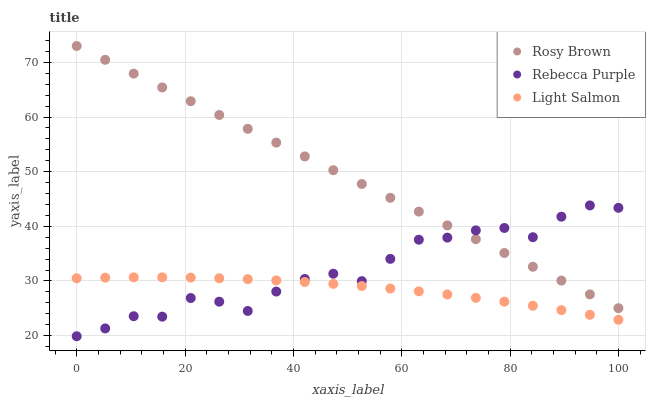Does Light Salmon have the minimum area under the curve?
Answer yes or no. Yes. Does Rosy Brown have the maximum area under the curve?
Answer yes or no. Yes. Does Rebecca Purple have the minimum area under the curve?
Answer yes or no. No. Does Rebecca Purple have the maximum area under the curve?
Answer yes or no. No. Is Rosy Brown the smoothest?
Answer yes or no. Yes. Is Rebecca Purple the roughest?
Answer yes or no. Yes. Is Rebecca Purple the smoothest?
Answer yes or no. No. Is Rosy Brown the roughest?
Answer yes or no. No. Does Rebecca Purple have the lowest value?
Answer yes or no. Yes. Does Rosy Brown have the lowest value?
Answer yes or no. No. Does Rosy Brown have the highest value?
Answer yes or no. Yes. Does Rebecca Purple have the highest value?
Answer yes or no. No. Is Light Salmon less than Rosy Brown?
Answer yes or no. Yes. Is Rosy Brown greater than Light Salmon?
Answer yes or no. Yes. Does Rebecca Purple intersect Rosy Brown?
Answer yes or no. Yes. Is Rebecca Purple less than Rosy Brown?
Answer yes or no. No. Is Rebecca Purple greater than Rosy Brown?
Answer yes or no. No. Does Light Salmon intersect Rosy Brown?
Answer yes or no. No. 